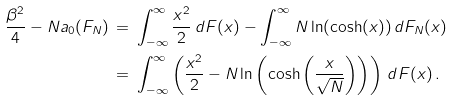Convert formula to latex. <formula><loc_0><loc_0><loc_500><loc_500>\frac { \beta ^ { 2 } } { 4 } - N a _ { 0 } ( F _ { N } ) \, & = \, \int _ { - \infty } ^ { \infty } \frac { x ^ { 2 } } { 2 } \, d F ( x ) - \int _ { - \infty } ^ { \infty } N \ln ( \cosh ( x ) ) \, d F _ { N } ( x ) \\ & = \, \int _ { - \infty } ^ { \infty } \left ( \frac { x ^ { 2 } } { 2 } - N \ln \left ( \cosh \left ( \frac { x } { \sqrt { N } } \right ) \right ) \right ) \, d F ( x ) \, .</formula> 